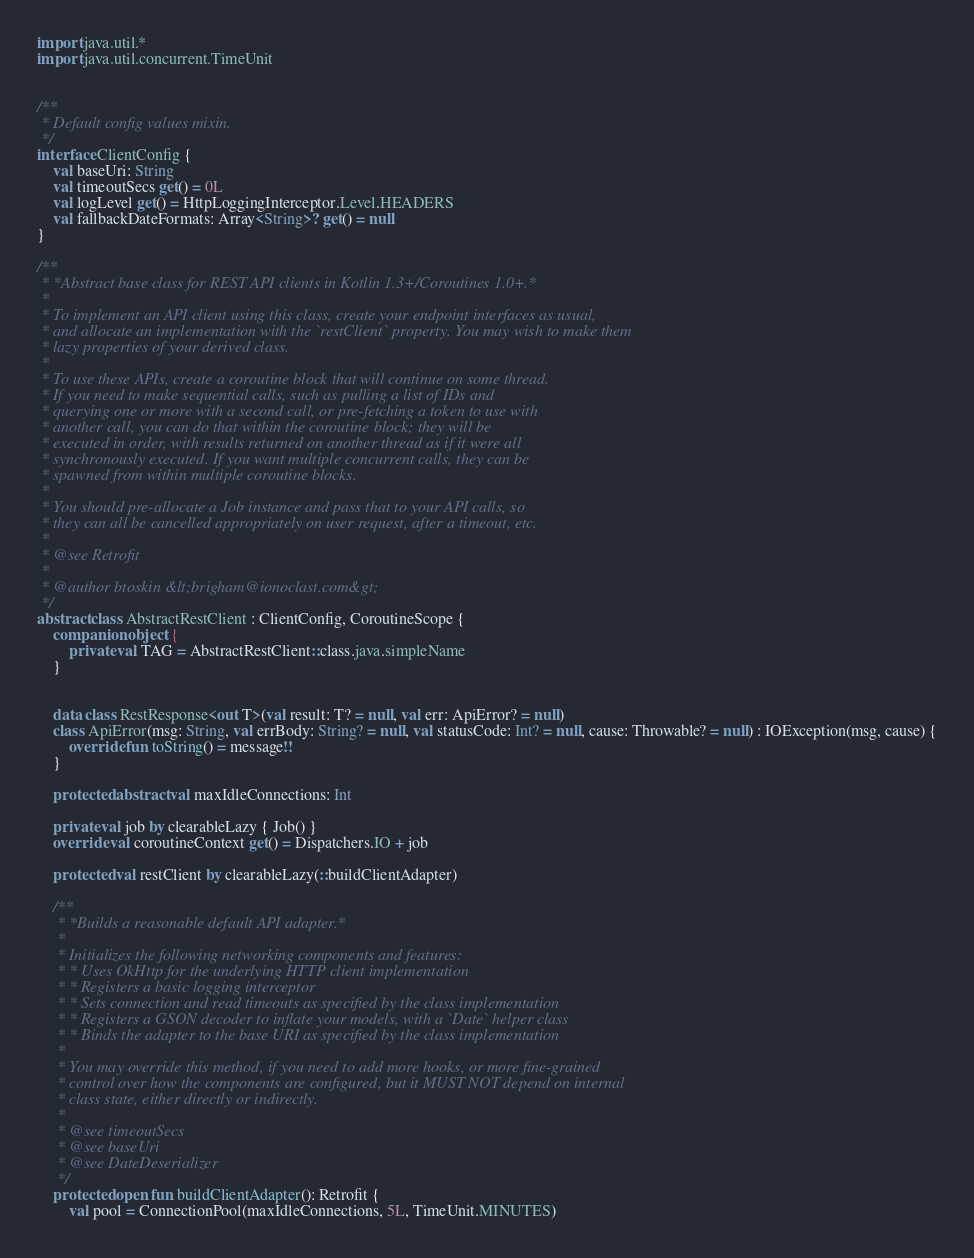<code> <loc_0><loc_0><loc_500><loc_500><_Kotlin_>import java.util.*
import java.util.concurrent.TimeUnit


/**
 * Default config values mixin.
 */
interface ClientConfig {
    val baseUri: String
    val timeoutSecs get() = 0L
    val logLevel get() = HttpLoggingInterceptor.Level.HEADERS
    val fallbackDateFormats: Array<String>? get() = null
}

/**
 * *Abstract base class for REST API clients in Kotlin 1.3+/Coroutines 1.0+.*
 *
 * To implement an API client using this class, create your endpoint interfaces as usual,
 * and allocate an implementation with the `restClient` property. You may wish to make them
 * lazy properties of your derived class.
 *
 * To use these APIs, create a coroutine block that will continue on some thread.
 * If you need to make sequential calls, such as pulling a list of IDs and
 * querying one or more with a second call, or pre-fetching a token to use with
 * another call, you can do that within the coroutine block; they will be
 * executed in order, with results returned on another thread as if it were all
 * synchronously executed. If you want multiple concurrent calls, they can be
 * spawned from within multiple coroutine blocks.
 *
 * You should pre-allocate a Job instance and pass that to your API calls, so
 * they can all be cancelled appropriately on user request, after a timeout, etc.
 *
 * @see Retrofit
 *
 * @author btoskin &lt;brigham@ionoclast.com&gt;
 */
abstract class AbstractRestClient : ClientConfig, CoroutineScope {
    companion object {
        private val TAG = AbstractRestClient::class.java.simpleName
    }


    data class RestResponse<out T>(val result: T? = null, val err: ApiError? = null)
    class ApiError(msg: String, val errBody: String? = null, val statusCode: Int? = null, cause: Throwable? = null) : IOException(msg, cause) {
        override fun toString() = message!!
    }

    protected abstract val maxIdleConnections: Int

    private val job by clearableLazy { Job() }
    override val coroutineContext get() = Dispatchers.IO + job

    protected val restClient by clearableLazy(::buildClientAdapter)

    /**
     * *Builds a reasonable default API adapter.*
     *
     * Initializes the following networking components and features:
     * * Uses OkHttp for the underlying HTTP client implementation
     * * Registers a basic logging interceptor
     * * Sets connection and read timeouts as specified by the class implementation
     * * Registers a GSON decoder to inflate your models, with a `Date` helper class
     * * Binds the adapter to the base URI as specified by the class implementation
     *
     * You may override this method, if you need to add more hooks, or more fine-grained
     * control over how the components are configured, but it MUST NOT depend on internal
     * class state, either directly or indirectly.
     *
     * @see timeoutSecs
     * @see baseUri
     * @see DateDeserializer
     */
    protected open fun buildClientAdapter(): Retrofit {
        val pool = ConnectionPool(maxIdleConnections, 5L, TimeUnit.MINUTES)</code> 